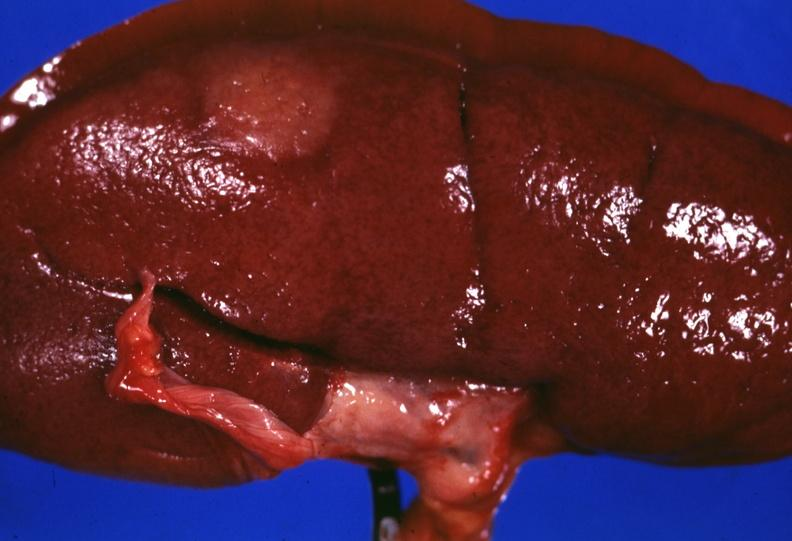where is this?
Answer the question using a single word or phrase. Urinary 